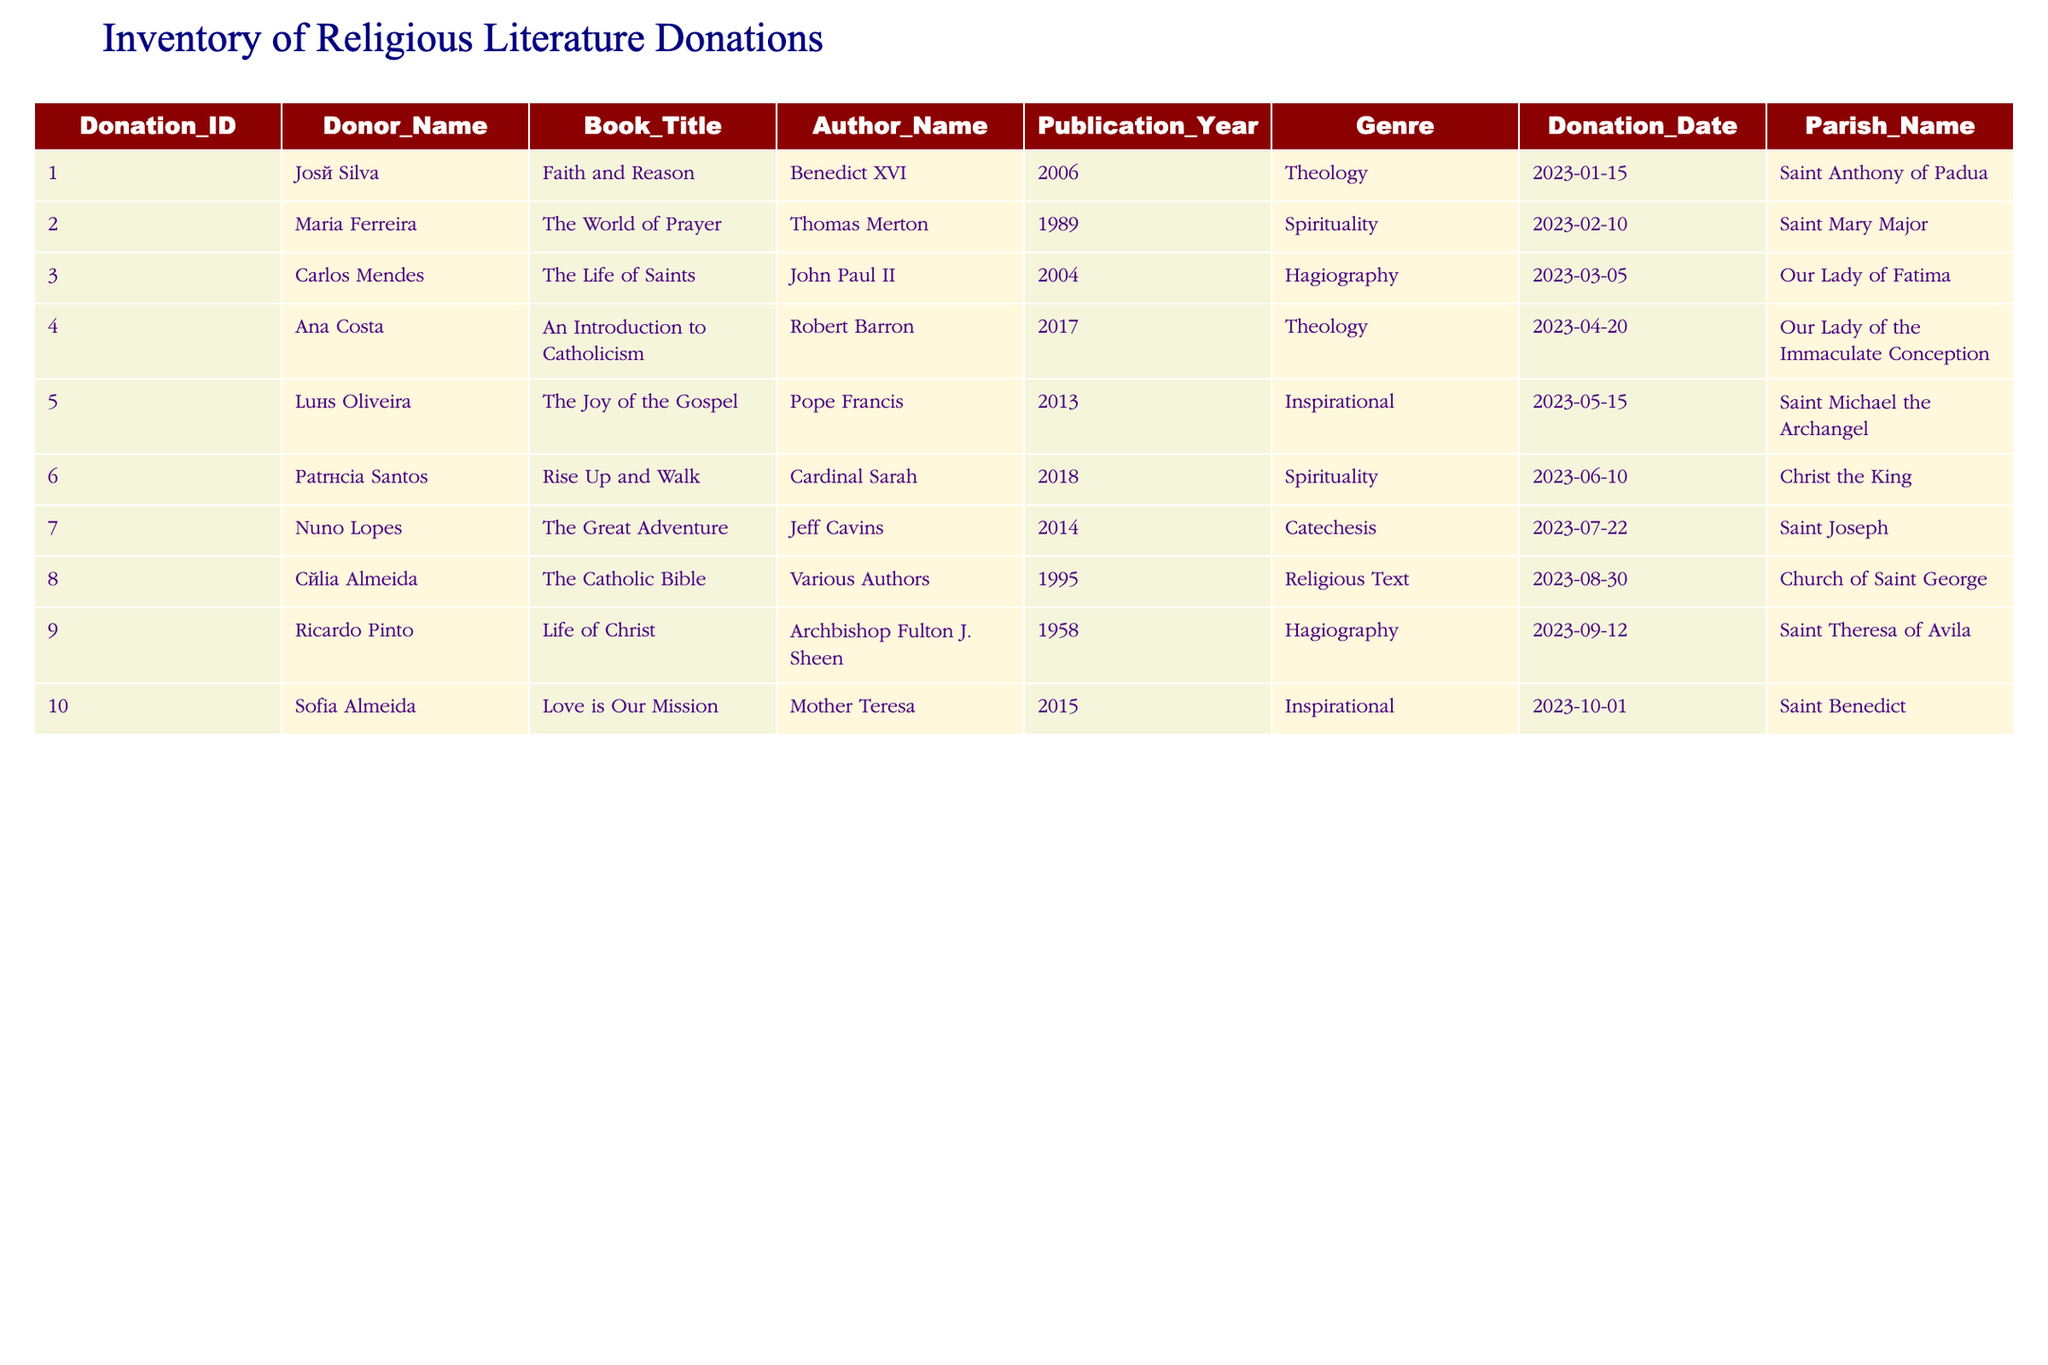What is the title of the book donated by José Silva? The table lists José Silva as the donor in the first row, with the corresponding book title listed as "Faith and Reason."
Answer: Faith and Reason How many books were donated to Saint Michael the Archangel? The table shows that Luís Oliveira donated "The Joy of the Gospel" to Saint Michael the Archangel, and no other entries indicate donations to this parish. Thus, there is only one book for this parish.
Answer: 1 Which author has the highest number of books donated? Reviewing the author names in the table reveals that Benedict XVI appears once alongside José Silva, Thomas Merton appears once with Maria Ferreira, John Paul II appears once with Carlos Mendes, Robert Barron appears once with Ana Costa, Pope Francis appears once with Luís Oliveira, Cardinal Sarah appears once with Patrícia Santos, Jeff Cavins appears once with Nuno Lopes, Various Authors appear once with Célia Almeida, Archbishop Fulton J. Sheen appears once with Ricardo Pinto, and Mother Teresa appears once with Sofia Almeida. Since all authors appear only once, there is no author with more than one donation.
Answer: None Was any book donated prior to 2000? Scanning through the publication years in the table shows that "The Life of Christ" by Archbishop Fulton J. Sheen is the only book published in 1958, which is before the year 2000. Therefore, yes, one book was donated before 2000.
Answer: Yes What is the average publication year of the donated books? To calculate the average, we first note the publication years: 2006, 1989, 2004, 2017, 2013, 2018, 2014, 1995, 1958, and 2015. Adding these years gives a total of 2006 + 1989 + 2004 + 2017 + 2013 + 2018 + 2014 + 1995 + 1958 + 2015 = 20019. There are 10 donations, so the average year is 20019 / 10 = 2001.9, which we round to 2002.
Answer: 2002 How many different parishes received donations? The table lists individual donations along with their parish names. Counting the unique parish names, we find: Saint Anthony of Padua, Saint Mary Major, Our Lady of Fatima, Our Lady of the Immaculate Conception, Saint Michael the Archangel, Christ the King, Saint Joseph, Church of Saint George, Saint Theresa of Avila, and Saint Benedict. This totals ten unique parishes.
Answer: 10 What genre does the book "Rise Up and Walk" belong to? Looking at the row that lists the book "Rise Up and Walk," we see that it is categorized under the genre "Spirituality."
Answer: Spirituality Which book was donated most recently? The donations are ordered by date, and the last entry in the table on the date column indicates that "Love is Our Mission" was donated on October 1, 2023, making it the most recent book donated.
Answer: Love is Our Mission 